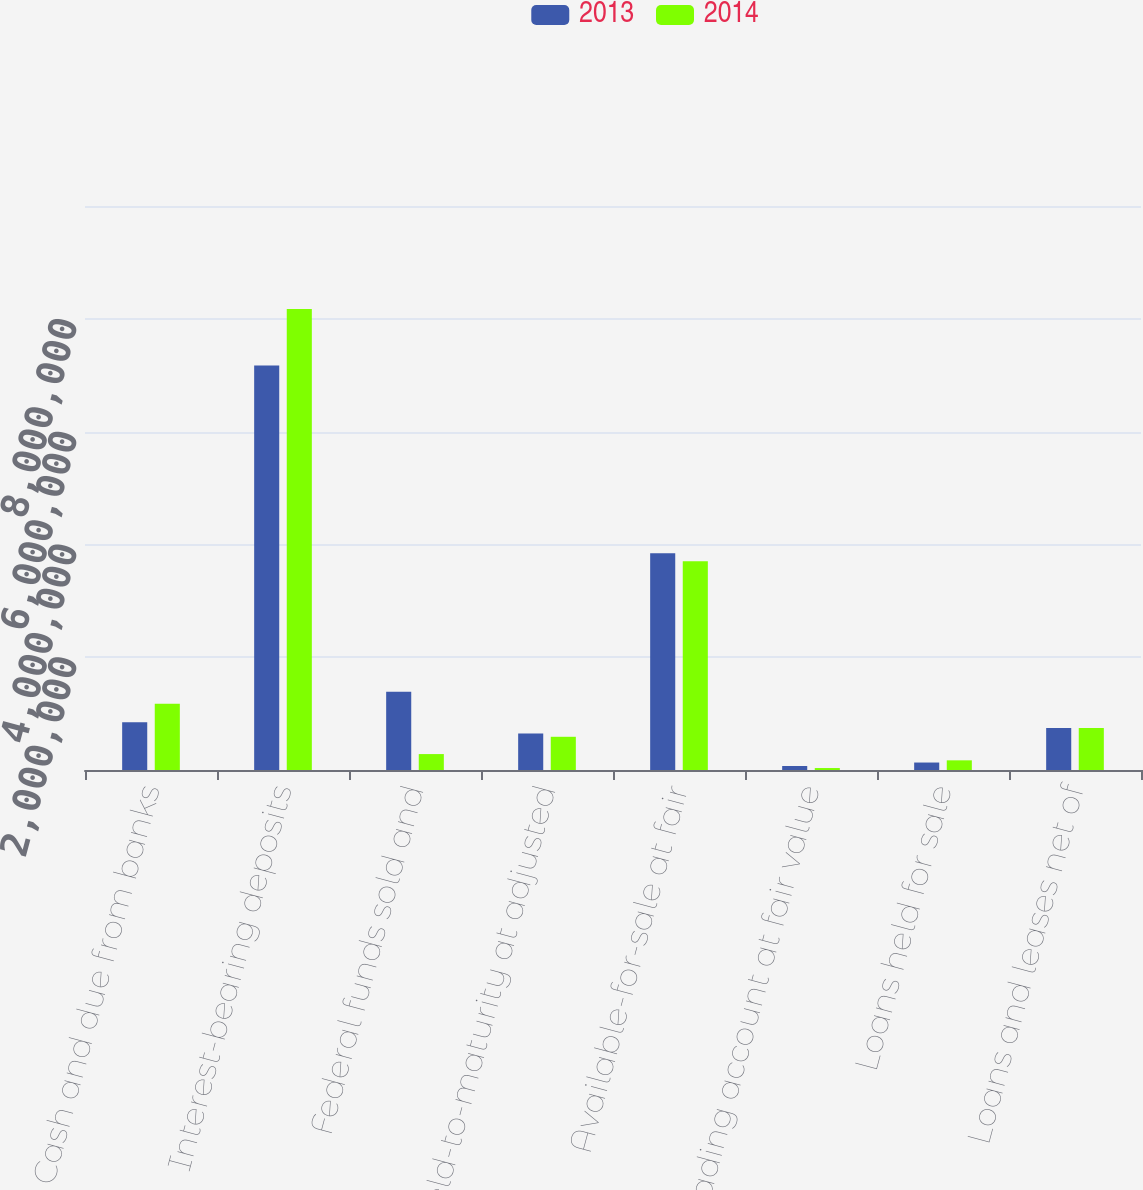Convert chart. <chart><loc_0><loc_0><loc_500><loc_500><stacked_bar_chart><ecel><fcel>Cash and due from banks<fcel>Interest-bearing deposits<fcel>Federal funds sold and<fcel>Held-to-maturity at adjusted<fcel>Available-for-sale at fair<fcel>Trading account at fair value<fcel>Loans held for sale<fcel>Loans and leases net of<nl><fcel>2013<fcel>845905<fcel>7.17413e+06<fcel>1.38629e+06<fcel>647252<fcel>3.84425e+06<fcel>70601<fcel>132504<fcel>746578<nl><fcel>2014<fcel>1.17508e+06<fcel>8.17505e+06<fcel>282248<fcel>588981<fcel>3.70189e+06<fcel>34559<fcel>171328<fcel>746578<nl></chart> 